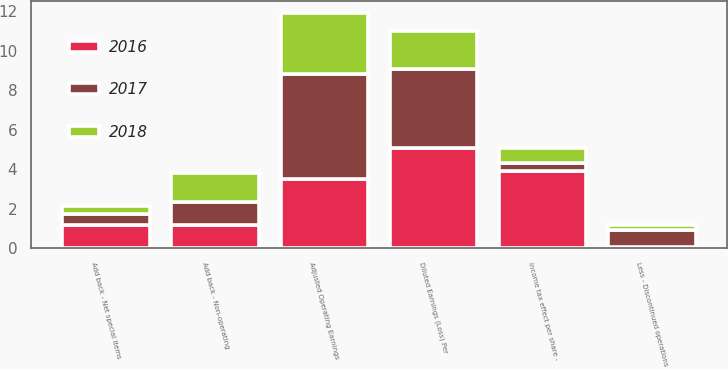Convert chart. <chart><loc_0><loc_0><loc_500><loc_500><stacked_bar_chart><ecel><fcel>Diluted Earnings (Loss) Per<fcel>Less - Discontinued operations<fcel>Add back - Non-operating<fcel>Add back - Net special items<fcel>Income tax effect per share -<fcel>Adjusted Operating Earnings<nl><fcel>2017<fcel>4.02<fcel>0.83<fcel>1.19<fcel>0.52<fcel>0.41<fcel>5.32<nl><fcel>2016<fcel>5.05<fcel>0.08<fcel>1.16<fcel>1.19<fcel>3.91<fcel>3.49<nl><fcel>2018<fcel>1.93<fcel>0.25<fcel>1.47<fcel>0.44<fcel>0.75<fcel>3.09<nl></chart> 